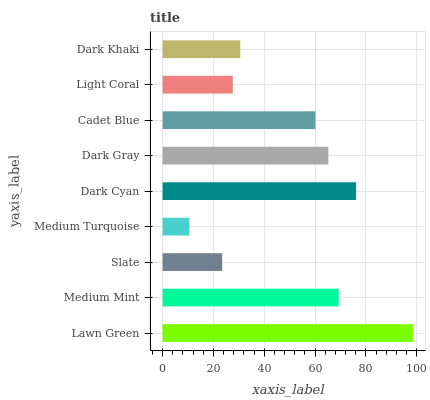Is Medium Turquoise the minimum?
Answer yes or no. Yes. Is Lawn Green the maximum?
Answer yes or no. Yes. Is Medium Mint the minimum?
Answer yes or no. No. Is Medium Mint the maximum?
Answer yes or no. No. Is Lawn Green greater than Medium Mint?
Answer yes or no. Yes. Is Medium Mint less than Lawn Green?
Answer yes or no. Yes. Is Medium Mint greater than Lawn Green?
Answer yes or no. No. Is Lawn Green less than Medium Mint?
Answer yes or no. No. Is Cadet Blue the high median?
Answer yes or no. Yes. Is Cadet Blue the low median?
Answer yes or no. Yes. Is Dark Cyan the high median?
Answer yes or no. No. Is Medium Mint the low median?
Answer yes or no. No. 